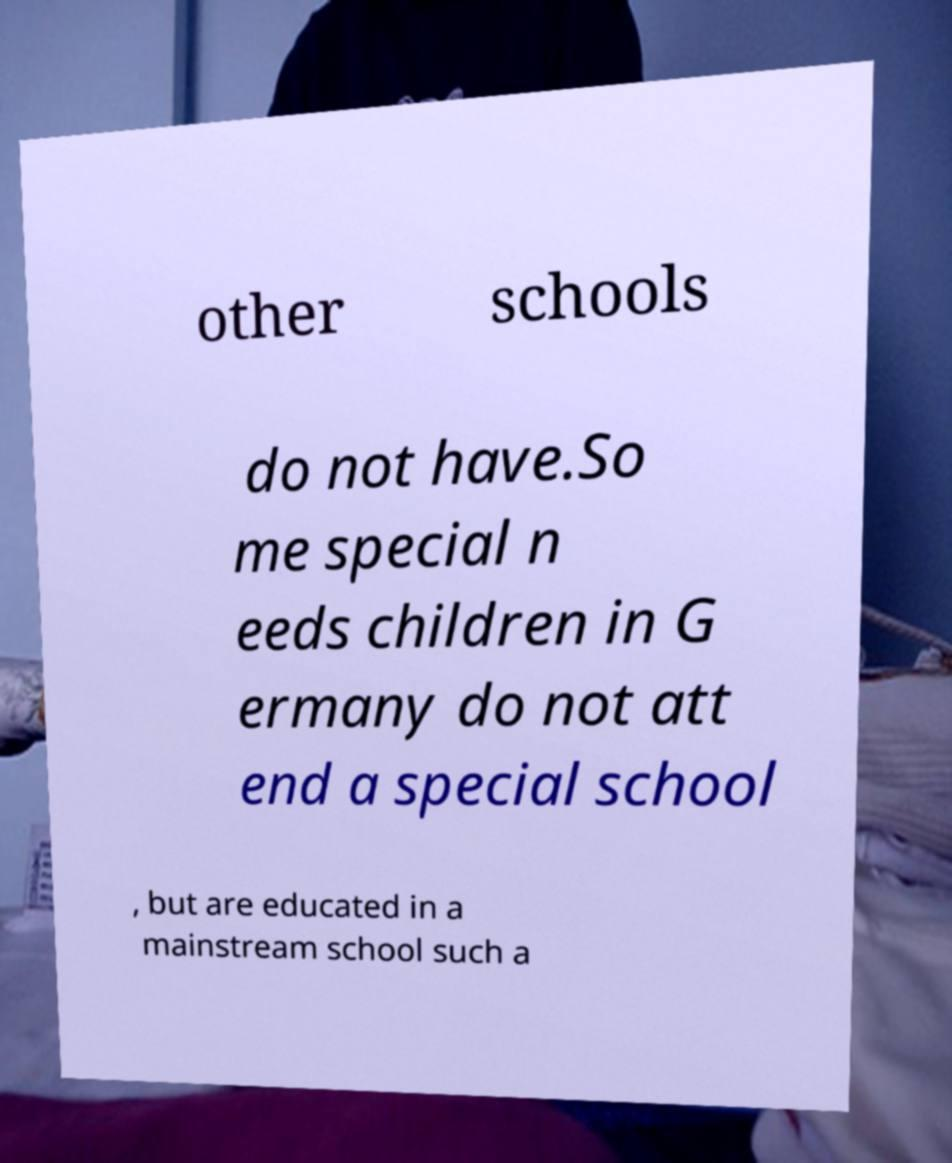There's text embedded in this image that I need extracted. Can you transcribe it verbatim? other schools do not have.So me special n eeds children in G ermany do not att end a special school , but are educated in a mainstream school such a 